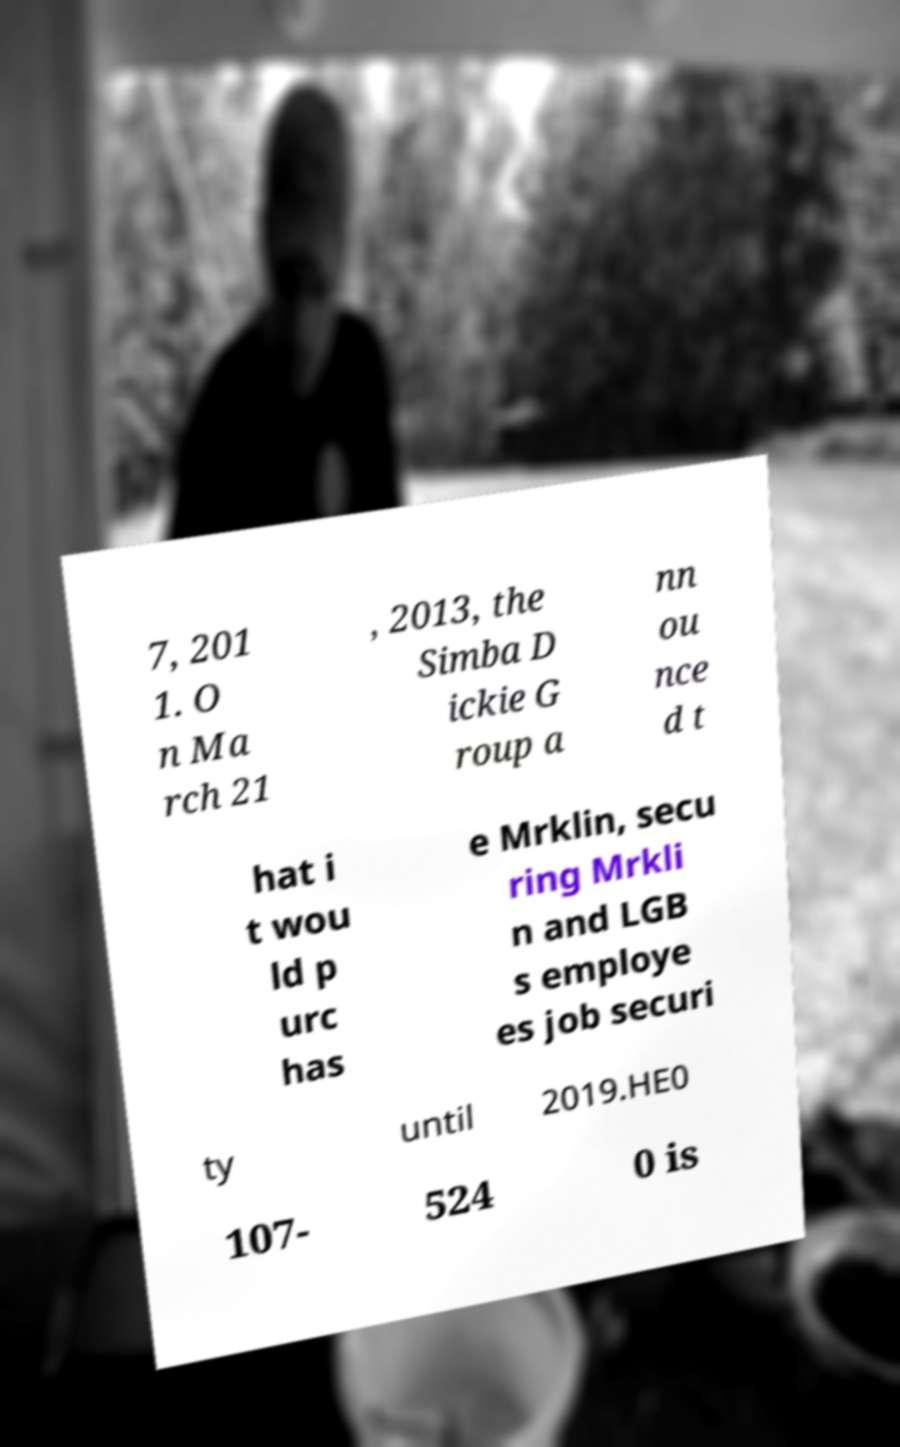Can you accurately transcribe the text from the provided image for me? 7, 201 1. O n Ma rch 21 , 2013, the Simba D ickie G roup a nn ou nce d t hat i t wou ld p urc has e Mrklin, secu ring Mrkli n and LGB s employe es job securi ty until 2019.HE0 107- 524 0 is 